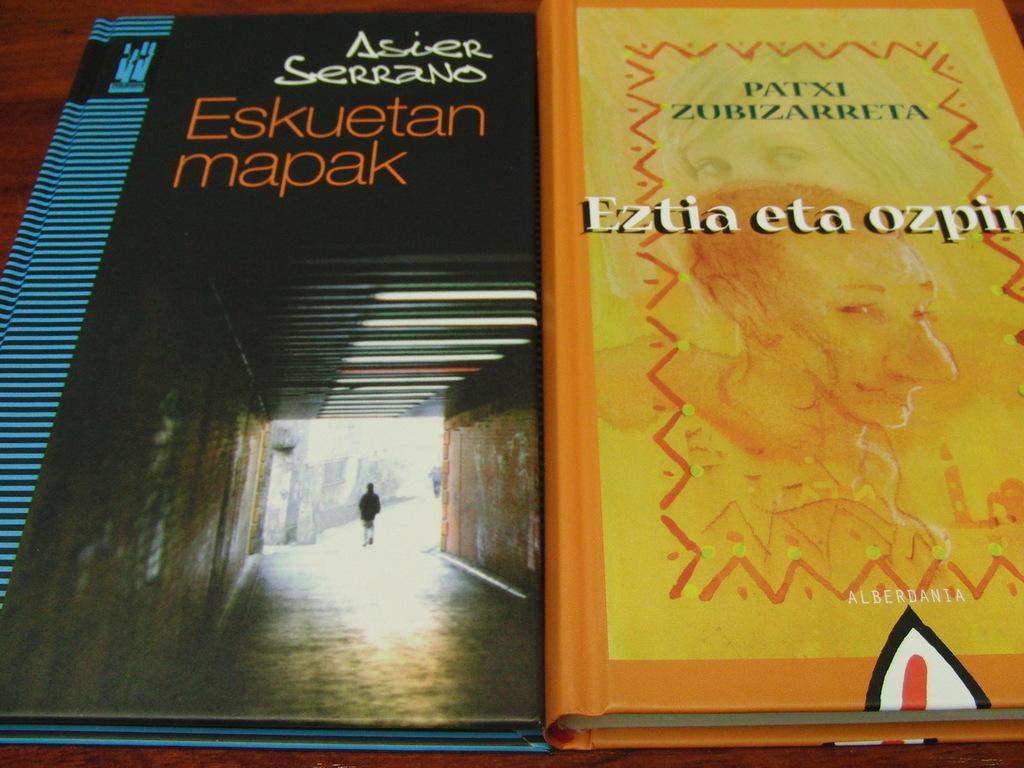Are these two books good sellers?
Give a very brief answer. Unanswerable. 